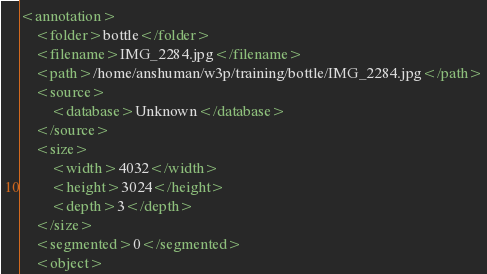<code> <loc_0><loc_0><loc_500><loc_500><_XML_><annotation>
	<folder>bottle</folder>
	<filename>IMG_2284.jpg</filename>
	<path>/home/anshuman/w3p/training/bottle/IMG_2284.jpg</path>
	<source>
		<database>Unknown</database>
	</source>
	<size>
		<width>4032</width>
		<height>3024</height>
		<depth>3</depth>
	</size>
	<segmented>0</segmented>
	<object></code> 